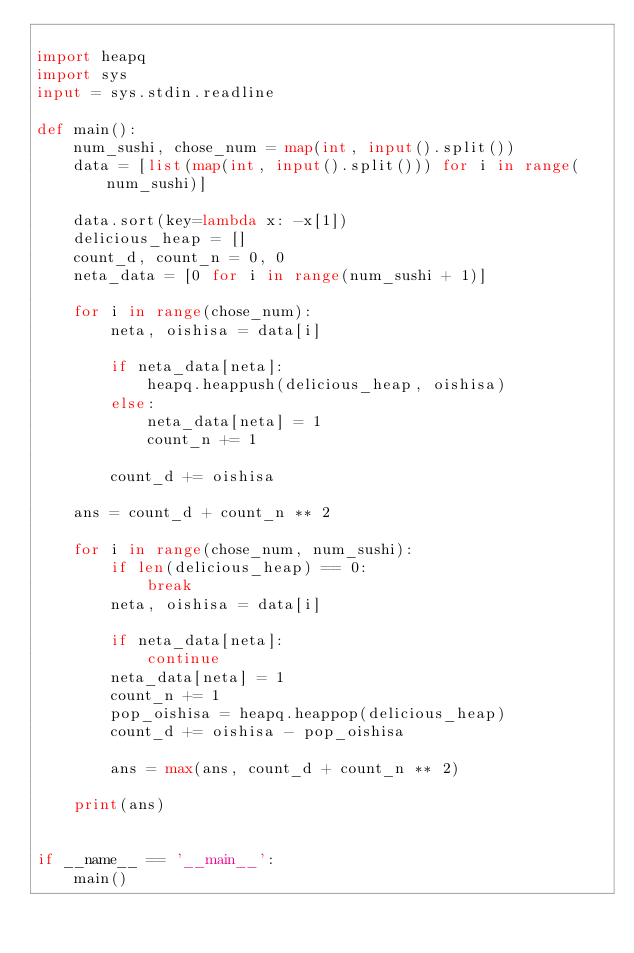Convert code to text. <code><loc_0><loc_0><loc_500><loc_500><_Python_>
import heapq
import sys
input = sys.stdin.readline

def main():
    num_sushi, chose_num = map(int, input().split())
    data = [list(map(int, input().split())) for i in range(num_sushi)]

    data.sort(key=lambda x: -x[1])
    delicious_heap = []
    count_d, count_n = 0, 0
    neta_data = [0 for i in range(num_sushi + 1)]

    for i in range(chose_num):
        neta, oishisa = data[i]

        if neta_data[neta]:
            heapq.heappush(delicious_heap, oishisa)
        else:
            neta_data[neta] = 1
            count_n += 1

        count_d += oishisa

    ans = count_d + count_n ** 2

    for i in range(chose_num, num_sushi):
        if len(delicious_heap) == 0:
            break
        neta, oishisa = data[i]

        if neta_data[neta]:
            continue
        neta_data[neta] = 1
        count_n += 1
        pop_oishisa = heapq.heappop(delicious_heap)
        count_d += oishisa - pop_oishisa

        ans = max(ans, count_d + count_n ** 2)

    print(ans)


if __name__ == '__main__':
    main()</code> 